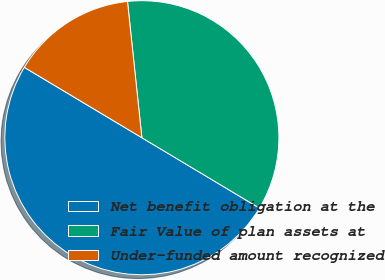Convert chart. <chart><loc_0><loc_0><loc_500><loc_500><pie_chart><fcel>Net benefit obligation at the<fcel>Fair Value of plan assets at<fcel>Under-funded amount recognized<nl><fcel>50.0%<fcel>35.26%<fcel>14.74%<nl></chart> 